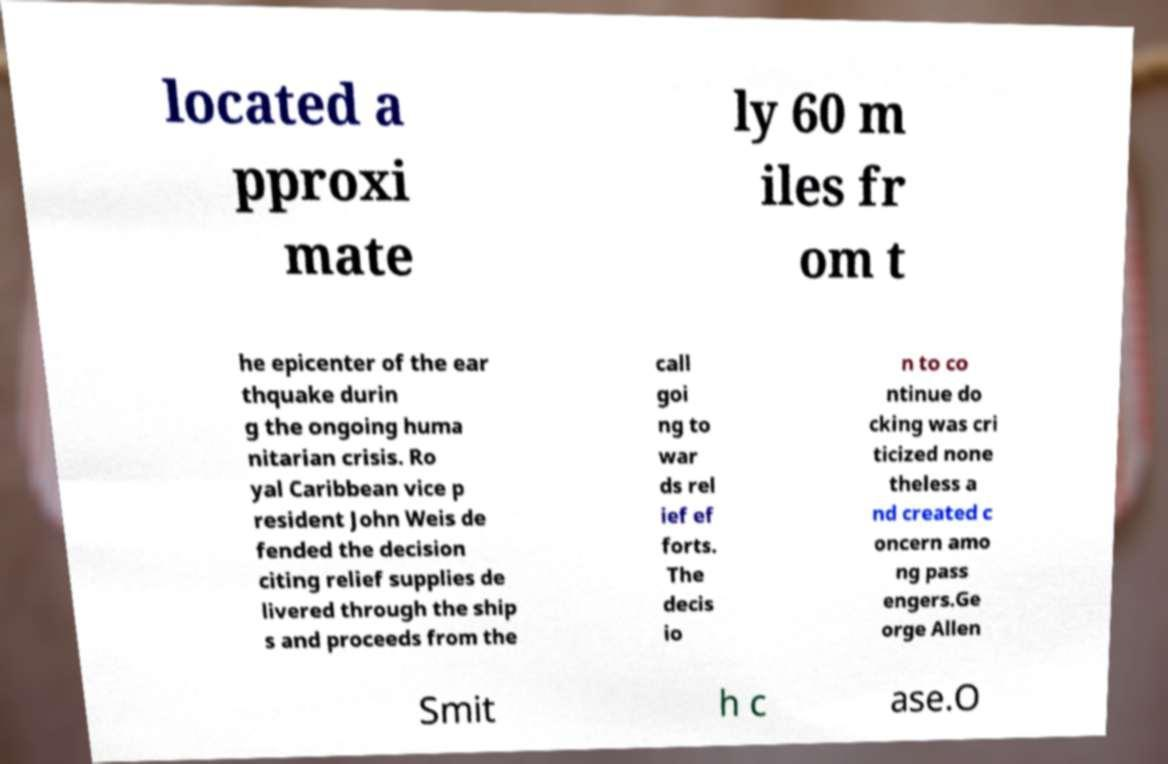Please read and relay the text visible in this image. What does it say? located a pproxi mate ly 60 m iles fr om t he epicenter of the ear thquake durin g the ongoing huma nitarian crisis. Ro yal Caribbean vice p resident John Weis de fended the decision citing relief supplies de livered through the ship s and proceeds from the call goi ng to war ds rel ief ef forts. The decis io n to co ntinue do cking was cri ticized none theless a nd created c oncern amo ng pass engers.Ge orge Allen Smit h c ase.O 